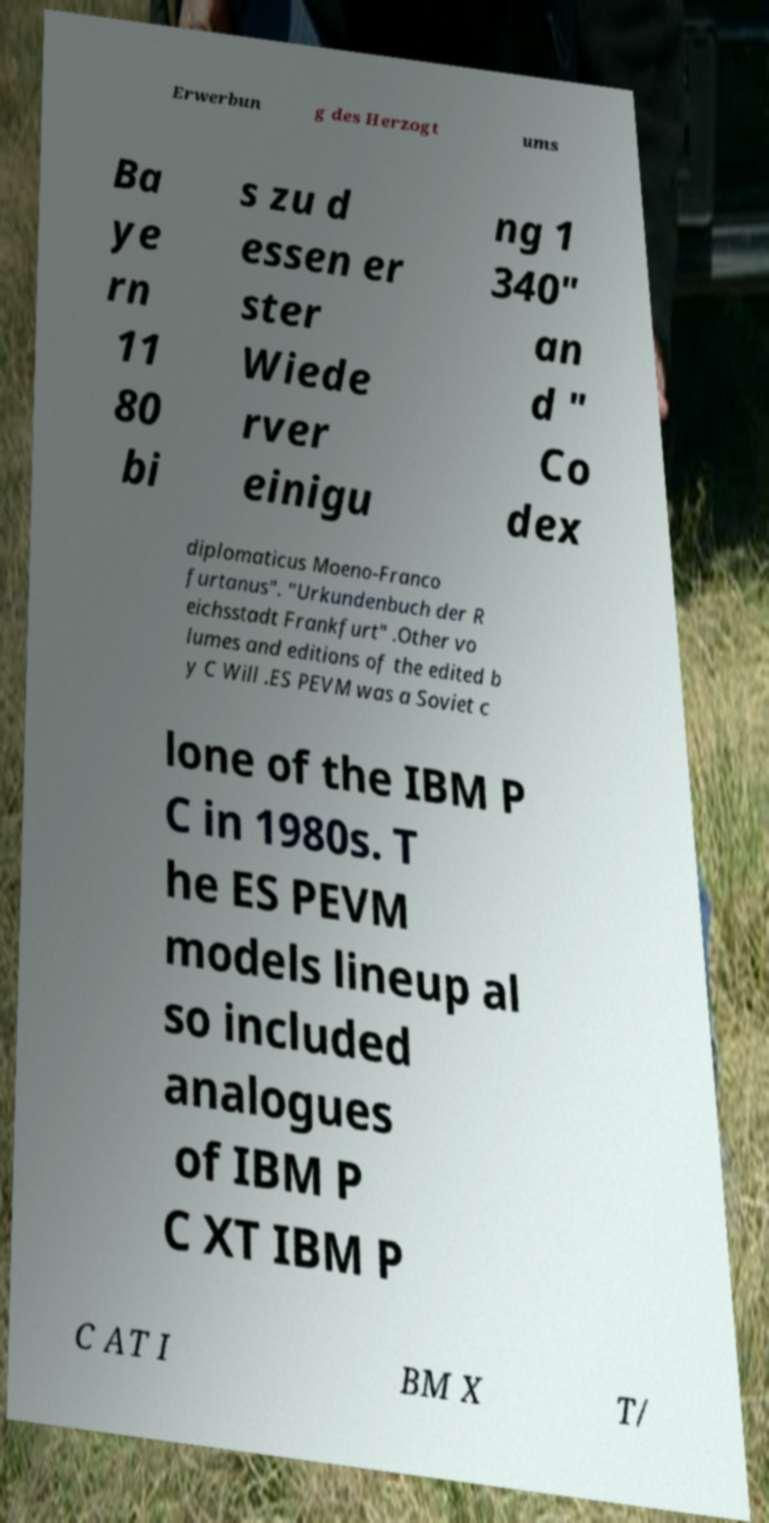I need the written content from this picture converted into text. Can you do that? Erwerbun g des Herzogt ums Ba ye rn 11 80 bi s zu d essen er ster Wiede rver einigu ng 1 340" an d " Co dex diplomaticus Moeno-Franco furtanus". "Urkundenbuch der R eichsstadt Frankfurt" .Other vo lumes and editions of the edited b y C Will .ES PEVM was a Soviet c lone of the IBM P C in 1980s. T he ES PEVM models lineup al so included analogues of IBM P C XT IBM P C AT I BM X T/ 